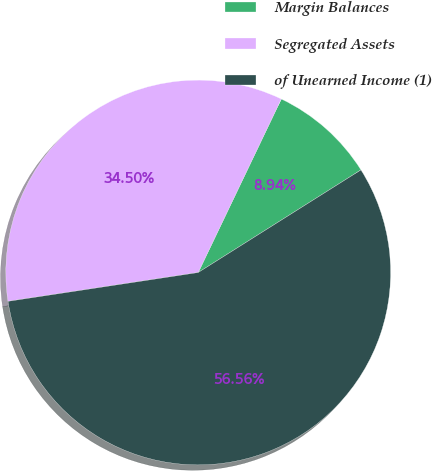<chart> <loc_0><loc_0><loc_500><loc_500><pie_chart><fcel>Margin Balances<fcel>Segregated Assets<fcel>of Unearned Income (1)<nl><fcel>8.94%<fcel>34.5%<fcel>56.56%<nl></chart> 